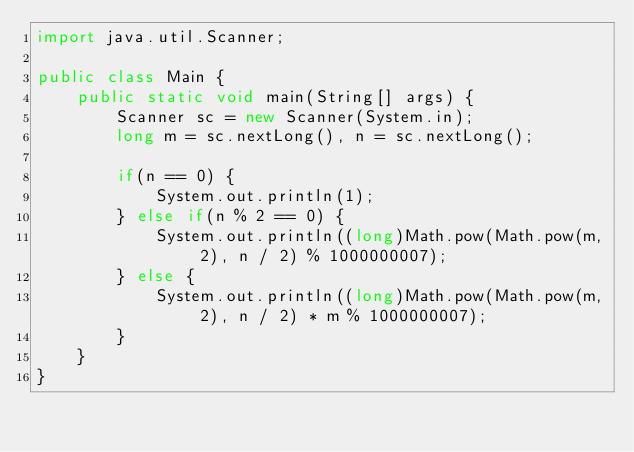<code> <loc_0><loc_0><loc_500><loc_500><_Java_>import java.util.Scanner;

public class Main {
    public static void main(String[] args) {
        Scanner sc = new Scanner(System.in);
        long m = sc.nextLong(), n = sc.nextLong();

        if(n == 0) {
            System.out.println(1);
        } else if(n % 2 == 0) {
            System.out.println((long)Math.pow(Math.pow(m, 2), n / 2) % 1000000007);
        } else {
            System.out.println((long)Math.pow(Math.pow(m, 2), n / 2) * m % 1000000007);
        }
    }
}</code> 